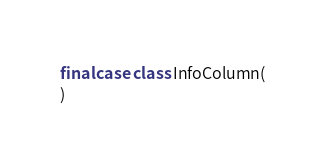<code> <loc_0><loc_0><loc_500><loc_500><_Scala_>final case class InfoColumn(
)
</code> 